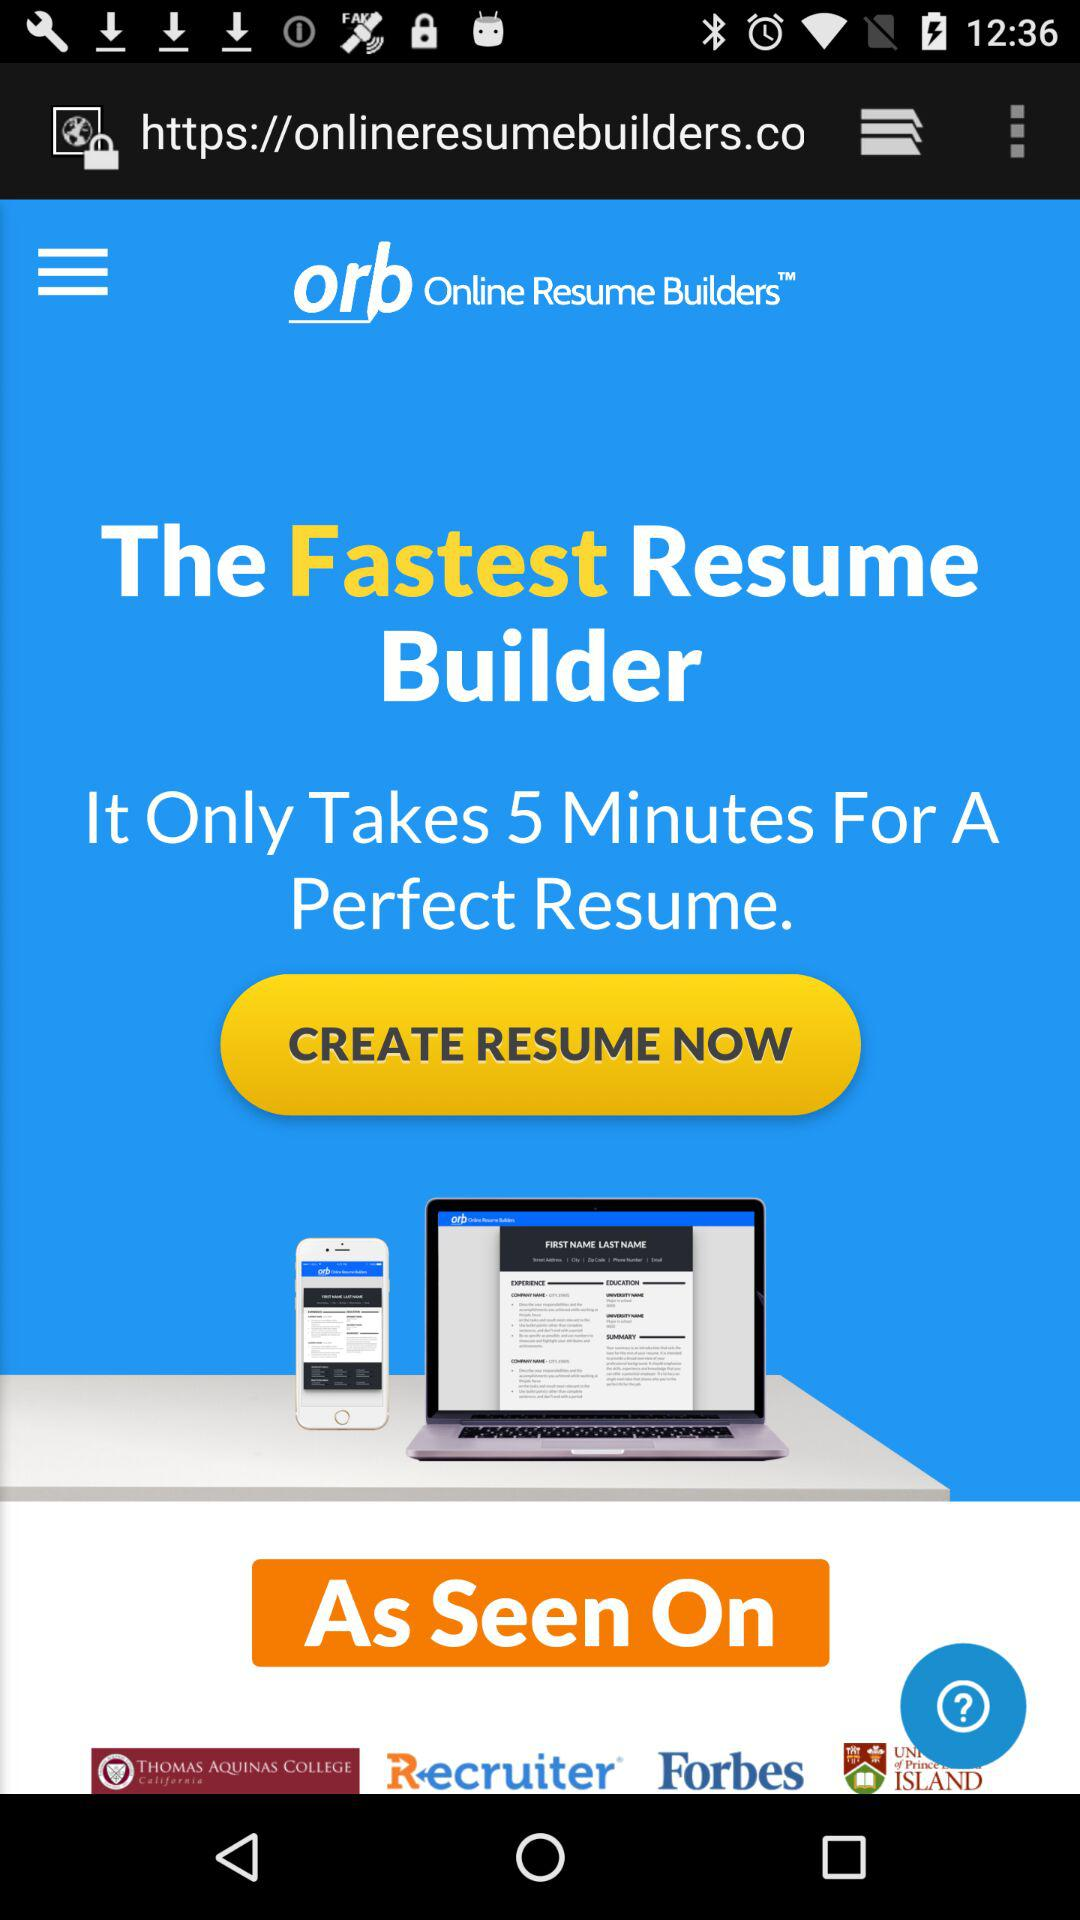How much does it cost to create a resume?
When the provided information is insufficient, respond with <no answer>. <no answer> 